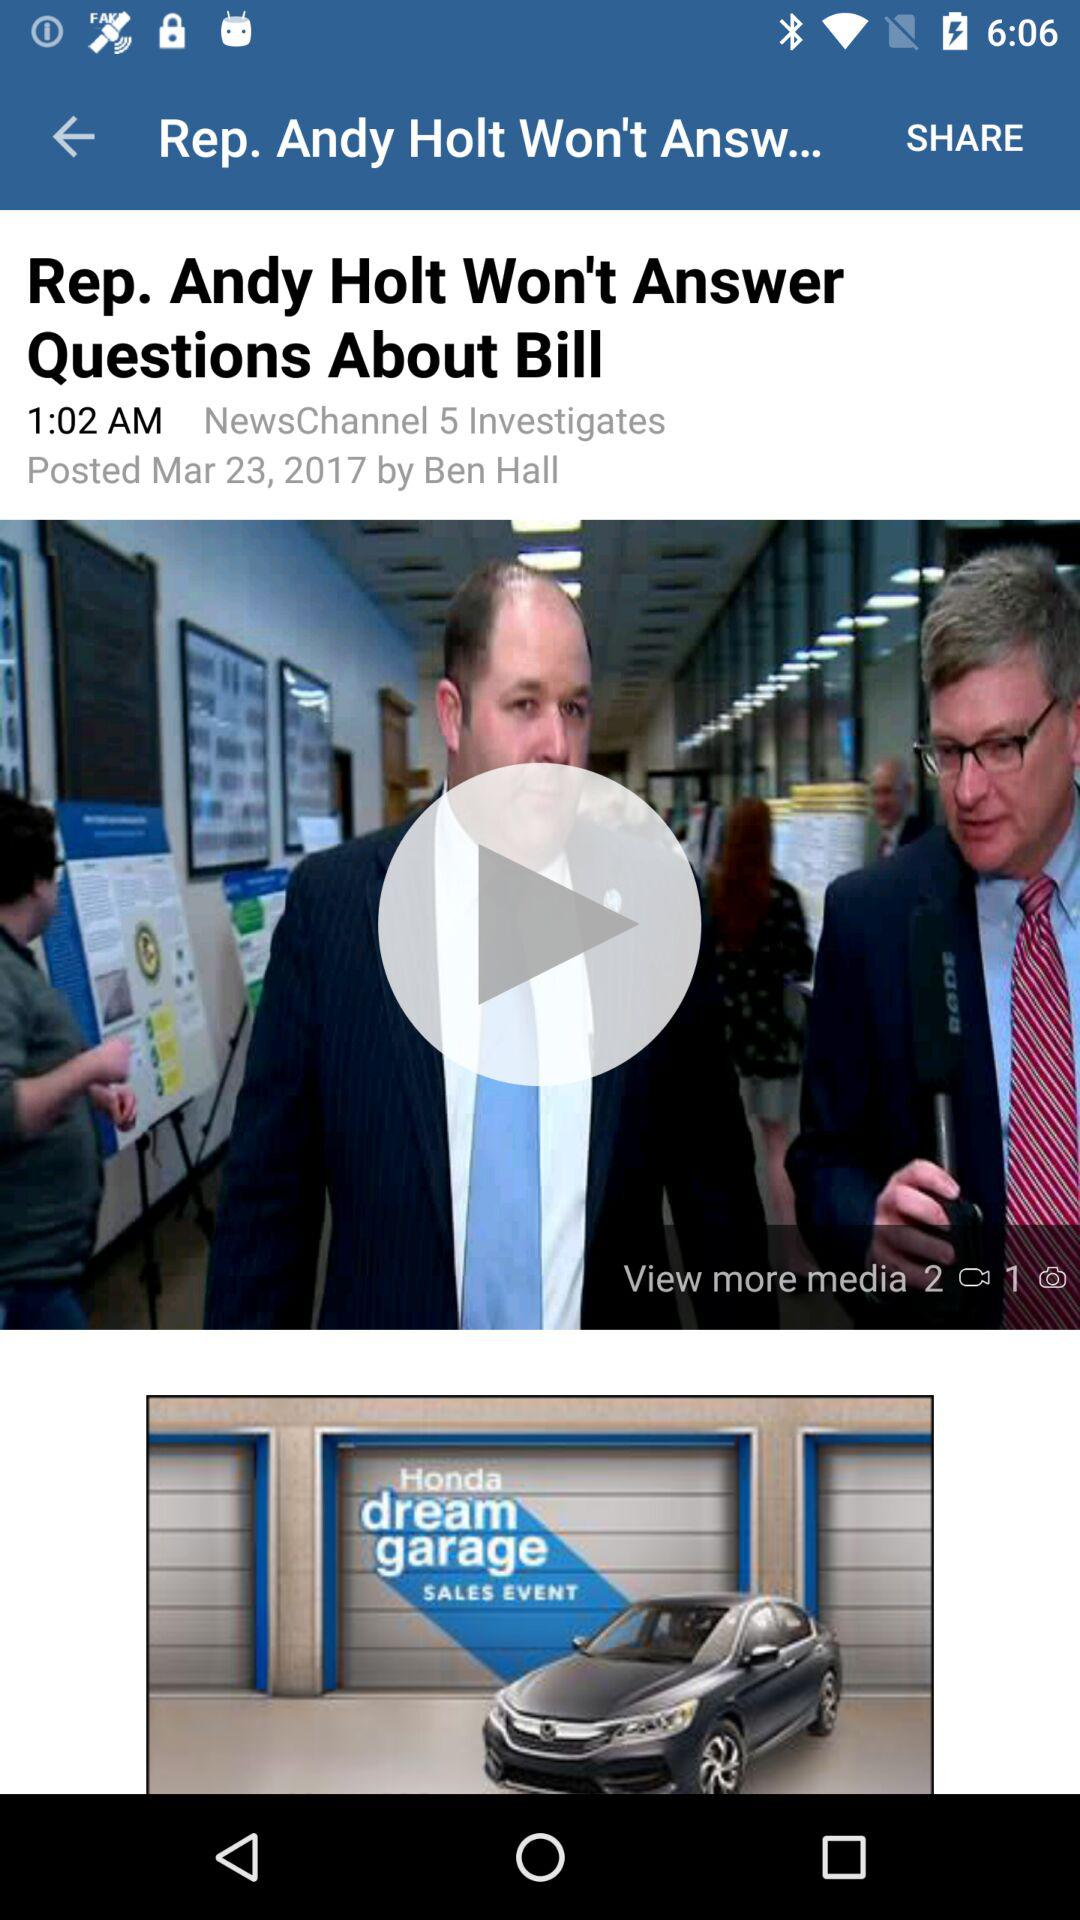What is the publication date? The publication date is March 23, 2017. 